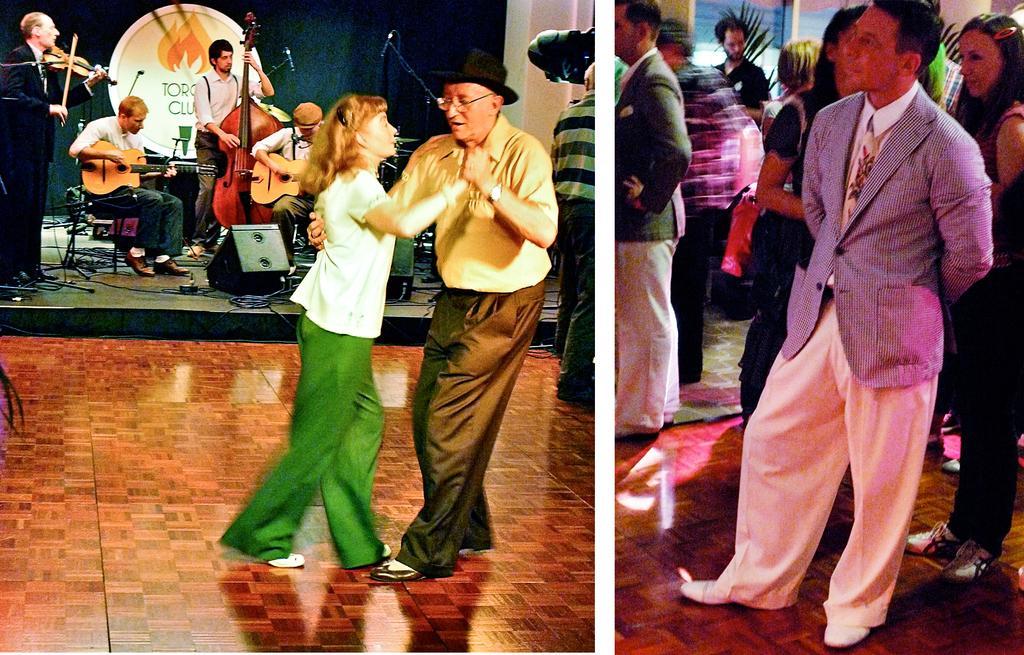Describe this image in one or two sentences. In the middle of the image a man holding a woman and dancing. Bottom left side of the image there is a floor. top left side of the image there is a musicians playing violin, guitar. Top right side of the image few people are standing and watching. 